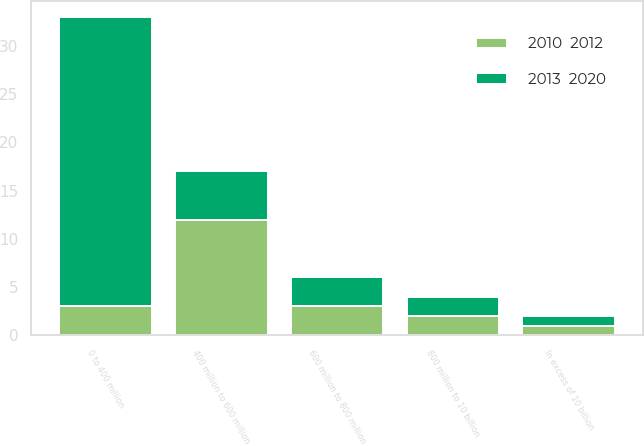<chart> <loc_0><loc_0><loc_500><loc_500><stacked_bar_chart><ecel><fcel>0 to 400 million<fcel>400 million to 600 million<fcel>600 million to 800 million<fcel>800 million to 10 billion<fcel>In excess of 10 billion<nl><fcel>2013  2020<fcel>30<fcel>5<fcel>3<fcel>2<fcel>1<nl><fcel>2010  2012<fcel>3<fcel>12<fcel>3<fcel>2<fcel>1<nl></chart> 